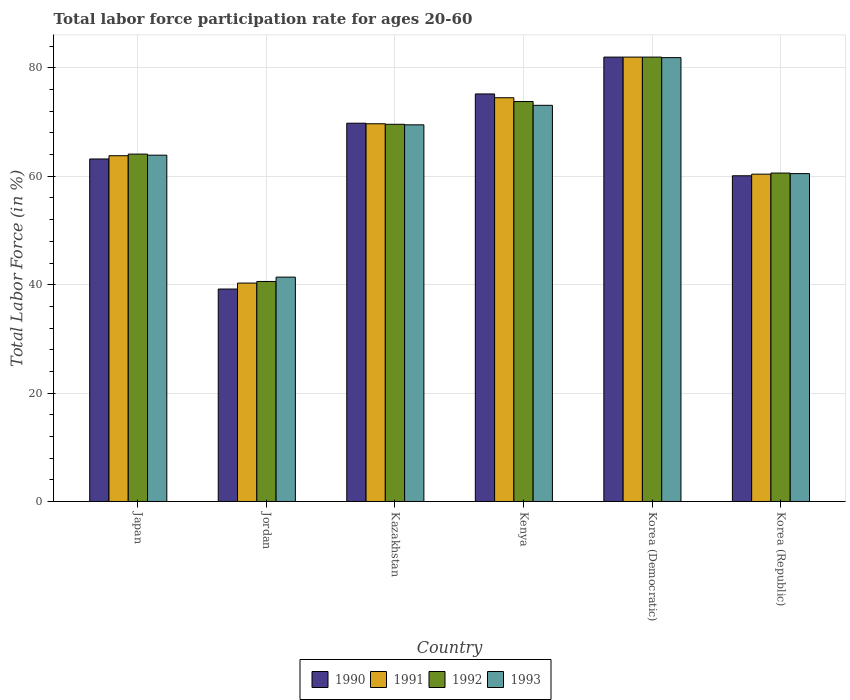Are the number of bars per tick equal to the number of legend labels?
Keep it short and to the point. Yes. Are the number of bars on each tick of the X-axis equal?
Ensure brevity in your answer.  Yes. How many bars are there on the 1st tick from the left?
Keep it short and to the point. 4. How many bars are there on the 2nd tick from the right?
Provide a short and direct response. 4. What is the label of the 1st group of bars from the left?
Keep it short and to the point. Japan. What is the labor force participation rate in 1992 in Japan?
Provide a short and direct response. 64.1. Across all countries, what is the maximum labor force participation rate in 1993?
Offer a terse response. 81.9. Across all countries, what is the minimum labor force participation rate in 1992?
Provide a short and direct response. 40.6. In which country was the labor force participation rate in 1993 maximum?
Provide a succinct answer. Korea (Democratic). In which country was the labor force participation rate in 1992 minimum?
Your answer should be very brief. Jordan. What is the total labor force participation rate in 1990 in the graph?
Keep it short and to the point. 389.5. What is the difference between the labor force participation rate in 1991 in Kazakhstan and that in Korea (Democratic)?
Offer a terse response. -12.3. What is the difference between the labor force participation rate in 1991 in Korea (Republic) and the labor force participation rate in 1990 in Japan?
Offer a terse response. -2.8. What is the average labor force participation rate in 1991 per country?
Offer a very short reply. 65.12. What is the difference between the labor force participation rate of/in 1991 and labor force participation rate of/in 1993 in Korea (Republic)?
Make the answer very short. -0.1. In how many countries, is the labor force participation rate in 1991 greater than 80 %?
Your answer should be very brief. 1. What is the ratio of the labor force participation rate in 1990 in Japan to that in Kenya?
Give a very brief answer. 0.84. Is the difference between the labor force participation rate in 1991 in Kazakhstan and Korea (Democratic) greater than the difference between the labor force participation rate in 1993 in Kazakhstan and Korea (Democratic)?
Make the answer very short. Yes. What is the difference between the highest and the second highest labor force participation rate in 1993?
Provide a succinct answer. -8.8. What is the difference between the highest and the lowest labor force participation rate in 1993?
Your answer should be very brief. 40.5. Is the sum of the labor force participation rate in 1992 in Jordan and Kenya greater than the maximum labor force participation rate in 1990 across all countries?
Ensure brevity in your answer.  Yes. Is it the case that in every country, the sum of the labor force participation rate in 1992 and labor force participation rate in 1991 is greater than the sum of labor force participation rate in 1990 and labor force participation rate in 1993?
Ensure brevity in your answer.  No. What does the 4th bar from the right in Jordan represents?
Provide a succinct answer. 1990. How many bars are there?
Your response must be concise. 24. How many countries are there in the graph?
Provide a succinct answer. 6. What is the difference between two consecutive major ticks on the Y-axis?
Offer a very short reply. 20. Are the values on the major ticks of Y-axis written in scientific E-notation?
Give a very brief answer. No. Does the graph contain any zero values?
Make the answer very short. No. Does the graph contain grids?
Offer a very short reply. Yes. Where does the legend appear in the graph?
Keep it short and to the point. Bottom center. What is the title of the graph?
Offer a very short reply. Total labor force participation rate for ages 20-60. Does "2002" appear as one of the legend labels in the graph?
Your response must be concise. No. What is the label or title of the Y-axis?
Keep it short and to the point. Total Labor Force (in %). What is the Total Labor Force (in %) of 1990 in Japan?
Your answer should be very brief. 63.2. What is the Total Labor Force (in %) in 1991 in Japan?
Make the answer very short. 63.8. What is the Total Labor Force (in %) of 1992 in Japan?
Provide a succinct answer. 64.1. What is the Total Labor Force (in %) of 1993 in Japan?
Provide a succinct answer. 63.9. What is the Total Labor Force (in %) of 1990 in Jordan?
Make the answer very short. 39.2. What is the Total Labor Force (in %) in 1991 in Jordan?
Your answer should be very brief. 40.3. What is the Total Labor Force (in %) in 1992 in Jordan?
Your response must be concise. 40.6. What is the Total Labor Force (in %) of 1993 in Jordan?
Provide a succinct answer. 41.4. What is the Total Labor Force (in %) in 1990 in Kazakhstan?
Provide a short and direct response. 69.8. What is the Total Labor Force (in %) of 1991 in Kazakhstan?
Provide a short and direct response. 69.7. What is the Total Labor Force (in %) in 1992 in Kazakhstan?
Your response must be concise. 69.6. What is the Total Labor Force (in %) in 1993 in Kazakhstan?
Give a very brief answer. 69.5. What is the Total Labor Force (in %) in 1990 in Kenya?
Provide a succinct answer. 75.2. What is the Total Labor Force (in %) in 1991 in Kenya?
Your answer should be compact. 74.5. What is the Total Labor Force (in %) in 1992 in Kenya?
Your answer should be compact. 73.8. What is the Total Labor Force (in %) in 1993 in Kenya?
Offer a very short reply. 73.1. What is the Total Labor Force (in %) in 1990 in Korea (Democratic)?
Ensure brevity in your answer.  82. What is the Total Labor Force (in %) of 1991 in Korea (Democratic)?
Your response must be concise. 82. What is the Total Labor Force (in %) in 1993 in Korea (Democratic)?
Your response must be concise. 81.9. What is the Total Labor Force (in %) in 1990 in Korea (Republic)?
Offer a terse response. 60.1. What is the Total Labor Force (in %) of 1991 in Korea (Republic)?
Ensure brevity in your answer.  60.4. What is the Total Labor Force (in %) in 1992 in Korea (Republic)?
Ensure brevity in your answer.  60.6. What is the Total Labor Force (in %) of 1993 in Korea (Republic)?
Offer a terse response. 60.5. Across all countries, what is the maximum Total Labor Force (in %) in 1991?
Give a very brief answer. 82. Across all countries, what is the maximum Total Labor Force (in %) of 1993?
Your answer should be compact. 81.9. Across all countries, what is the minimum Total Labor Force (in %) of 1990?
Your answer should be very brief. 39.2. Across all countries, what is the minimum Total Labor Force (in %) of 1991?
Provide a short and direct response. 40.3. Across all countries, what is the minimum Total Labor Force (in %) of 1992?
Your answer should be very brief. 40.6. Across all countries, what is the minimum Total Labor Force (in %) in 1993?
Your answer should be compact. 41.4. What is the total Total Labor Force (in %) of 1990 in the graph?
Keep it short and to the point. 389.5. What is the total Total Labor Force (in %) of 1991 in the graph?
Your answer should be very brief. 390.7. What is the total Total Labor Force (in %) in 1992 in the graph?
Keep it short and to the point. 390.7. What is the total Total Labor Force (in %) of 1993 in the graph?
Provide a short and direct response. 390.3. What is the difference between the Total Labor Force (in %) of 1993 in Japan and that in Jordan?
Offer a terse response. 22.5. What is the difference between the Total Labor Force (in %) in 1990 in Japan and that in Kazakhstan?
Provide a succinct answer. -6.6. What is the difference between the Total Labor Force (in %) of 1992 in Japan and that in Kazakhstan?
Provide a short and direct response. -5.5. What is the difference between the Total Labor Force (in %) in 1993 in Japan and that in Kazakhstan?
Provide a succinct answer. -5.6. What is the difference between the Total Labor Force (in %) of 1990 in Japan and that in Korea (Democratic)?
Your answer should be compact. -18.8. What is the difference between the Total Labor Force (in %) of 1991 in Japan and that in Korea (Democratic)?
Ensure brevity in your answer.  -18.2. What is the difference between the Total Labor Force (in %) of 1992 in Japan and that in Korea (Democratic)?
Offer a terse response. -17.9. What is the difference between the Total Labor Force (in %) in 1990 in Japan and that in Korea (Republic)?
Your response must be concise. 3.1. What is the difference between the Total Labor Force (in %) of 1991 in Japan and that in Korea (Republic)?
Your answer should be compact. 3.4. What is the difference between the Total Labor Force (in %) in 1990 in Jordan and that in Kazakhstan?
Provide a short and direct response. -30.6. What is the difference between the Total Labor Force (in %) in 1991 in Jordan and that in Kazakhstan?
Provide a succinct answer. -29.4. What is the difference between the Total Labor Force (in %) in 1992 in Jordan and that in Kazakhstan?
Offer a very short reply. -29. What is the difference between the Total Labor Force (in %) of 1993 in Jordan and that in Kazakhstan?
Give a very brief answer. -28.1. What is the difference between the Total Labor Force (in %) in 1990 in Jordan and that in Kenya?
Your answer should be very brief. -36. What is the difference between the Total Labor Force (in %) in 1991 in Jordan and that in Kenya?
Make the answer very short. -34.2. What is the difference between the Total Labor Force (in %) in 1992 in Jordan and that in Kenya?
Make the answer very short. -33.2. What is the difference between the Total Labor Force (in %) of 1993 in Jordan and that in Kenya?
Provide a short and direct response. -31.7. What is the difference between the Total Labor Force (in %) in 1990 in Jordan and that in Korea (Democratic)?
Provide a succinct answer. -42.8. What is the difference between the Total Labor Force (in %) of 1991 in Jordan and that in Korea (Democratic)?
Your answer should be compact. -41.7. What is the difference between the Total Labor Force (in %) in 1992 in Jordan and that in Korea (Democratic)?
Give a very brief answer. -41.4. What is the difference between the Total Labor Force (in %) in 1993 in Jordan and that in Korea (Democratic)?
Your response must be concise. -40.5. What is the difference between the Total Labor Force (in %) in 1990 in Jordan and that in Korea (Republic)?
Provide a short and direct response. -20.9. What is the difference between the Total Labor Force (in %) in 1991 in Jordan and that in Korea (Republic)?
Your answer should be very brief. -20.1. What is the difference between the Total Labor Force (in %) in 1993 in Jordan and that in Korea (Republic)?
Keep it short and to the point. -19.1. What is the difference between the Total Labor Force (in %) of 1991 in Kazakhstan and that in Kenya?
Ensure brevity in your answer.  -4.8. What is the difference between the Total Labor Force (in %) of 1992 in Kazakhstan and that in Kenya?
Make the answer very short. -4.2. What is the difference between the Total Labor Force (in %) of 1990 in Kazakhstan and that in Korea (Democratic)?
Provide a succinct answer. -12.2. What is the difference between the Total Labor Force (in %) in 1993 in Kazakhstan and that in Korea (Democratic)?
Offer a terse response. -12.4. What is the difference between the Total Labor Force (in %) in 1990 in Kazakhstan and that in Korea (Republic)?
Provide a succinct answer. 9.7. What is the difference between the Total Labor Force (in %) in 1991 in Kazakhstan and that in Korea (Republic)?
Your answer should be compact. 9.3. What is the difference between the Total Labor Force (in %) in 1993 in Kazakhstan and that in Korea (Republic)?
Ensure brevity in your answer.  9. What is the difference between the Total Labor Force (in %) of 1991 in Kenya and that in Korea (Democratic)?
Give a very brief answer. -7.5. What is the difference between the Total Labor Force (in %) in 1993 in Kenya and that in Korea (Democratic)?
Your response must be concise. -8.8. What is the difference between the Total Labor Force (in %) of 1990 in Korea (Democratic) and that in Korea (Republic)?
Your response must be concise. 21.9. What is the difference between the Total Labor Force (in %) of 1991 in Korea (Democratic) and that in Korea (Republic)?
Provide a succinct answer. 21.6. What is the difference between the Total Labor Force (in %) of 1992 in Korea (Democratic) and that in Korea (Republic)?
Keep it short and to the point. 21.4. What is the difference between the Total Labor Force (in %) in 1993 in Korea (Democratic) and that in Korea (Republic)?
Make the answer very short. 21.4. What is the difference between the Total Labor Force (in %) of 1990 in Japan and the Total Labor Force (in %) of 1991 in Jordan?
Your answer should be very brief. 22.9. What is the difference between the Total Labor Force (in %) of 1990 in Japan and the Total Labor Force (in %) of 1992 in Jordan?
Provide a succinct answer. 22.6. What is the difference between the Total Labor Force (in %) in 1990 in Japan and the Total Labor Force (in %) in 1993 in Jordan?
Your answer should be very brief. 21.8. What is the difference between the Total Labor Force (in %) of 1991 in Japan and the Total Labor Force (in %) of 1992 in Jordan?
Offer a terse response. 23.2. What is the difference between the Total Labor Force (in %) of 1991 in Japan and the Total Labor Force (in %) of 1993 in Jordan?
Your answer should be very brief. 22.4. What is the difference between the Total Labor Force (in %) in 1992 in Japan and the Total Labor Force (in %) in 1993 in Jordan?
Offer a terse response. 22.7. What is the difference between the Total Labor Force (in %) of 1990 in Japan and the Total Labor Force (in %) of 1993 in Kazakhstan?
Keep it short and to the point. -6.3. What is the difference between the Total Labor Force (in %) in 1991 in Japan and the Total Labor Force (in %) in 1993 in Kazakhstan?
Provide a succinct answer. -5.7. What is the difference between the Total Labor Force (in %) in 1992 in Japan and the Total Labor Force (in %) in 1993 in Kazakhstan?
Provide a short and direct response. -5.4. What is the difference between the Total Labor Force (in %) in 1990 in Japan and the Total Labor Force (in %) in 1992 in Kenya?
Offer a very short reply. -10.6. What is the difference between the Total Labor Force (in %) of 1990 in Japan and the Total Labor Force (in %) of 1993 in Kenya?
Offer a terse response. -9.9. What is the difference between the Total Labor Force (in %) in 1991 in Japan and the Total Labor Force (in %) in 1992 in Kenya?
Provide a short and direct response. -10. What is the difference between the Total Labor Force (in %) in 1991 in Japan and the Total Labor Force (in %) in 1993 in Kenya?
Your answer should be compact. -9.3. What is the difference between the Total Labor Force (in %) in 1990 in Japan and the Total Labor Force (in %) in 1991 in Korea (Democratic)?
Keep it short and to the point. -18.8. What is the difference between the Total Labor Force (in %) of 1990 in Japan and the Total Labor Force (in %) of 1992 in Korea (Democratic)?
Ensure brevity in your answer.  -18.8. What is the difference between the Total Labor Force (in %) in 1990 in Japan and the Total Labor Force (in %) in 1993 in Korea (Democratic)?
Offer a terse response. -18.7. What is the difference between the Total Labor Force (in %) of 1991 in Japan and the Total Labor Force (in %) of 1992 in Korea (Democratic)?
Your answer should be very brief. -18.2. What is the difference between the Total Labor Force (in %) of 1991 in Japan and the Total Labor Force (in %) of 1993 in Korea (Democratic)?
Offer a terse response. -18.1. What is the difference between the Total Labor Force (in %) of 1992 in Japan and the Total Labor Force (in %) of 1993 in Korea (Democratic)?
Provide a short and direct response. -17.8. What is the difference between the Total Labor Force (in %) of 1990 in Japan and the Total Labor Force (in %) of 1992 in Korea (Republic)?
Your answer should be very brief. 2.6. What is the difference between the Total Labor Force (in %) in 1990 in Japan and the Total Labor Force (in %) in 1993 in Korea (Republic)?
Give a very brief answer. 2.7. What is the difference between the Total Labor Force (in %) in 1991 in Japan and the Total Labor Force (in %) in 1992 in Korea (Republic)?
Offer a very short reply. 3.2. What is the difference between the Total Labor Force (in %) in 1992 in Japan and the Total Labor Force (in %) in 1993 in Korea (Republic)?
Offer a very short reply. 3.6. What is the difference between the Total Labor Force (in %) of 1990 in Jordan and the Total Labor Force (in %) of 1991 in Kazakhstan?
Your answer should be very brief. -30.5. What is the difference between the Total Labor Force (in %) in 1990 in Jordan and the Total Labor Force (in %) in 1992 in Kazakhstan?
Offer a very short reply. -30.4. What is the difference between the Total Labor Force (in %) of 1990 in Jordan and the Total Labor Force (in %) of 1993 in Kazakhstan?
Give a very brief answer. -30.3. What is the difference between the Total Labor Force (in %) in 1991 in Jordan and the Total Labor Force (in %) in 1992 in Kazakhstan?
Offer a very short reply. -29.3. What is the difference between the Total Labor Force (in %) in 1991 in Jordan and the Total Labor Force (in %) in 1993 in Kazakhstan?
Your answer should be very brief. -29.2. What is the difference between the Total Labor Force (in %) of 1992 in Jordan and the Total Labor Force (in %) of 1993 in Kazakhstan?
Make the answer very short. -28.9. What is the difference between the Total Labor Force (in %) in 1990 in Jordan and the Total Labor Force (in %) in 1991 in Kenya?
Your answer should be compact. -35.3. What is the difference between the Total Labor Force (in %) in 1990 in Jordan and the Total Labor Force (in %) in 1992 in Kenya?
Provide a short and direct response. -34.6. What is the difference between the Total Labor Force (in %) in 1990 in Jordan and the Total Labor Force (in %) in 1993 in Kenya?
Your answer should be compact. -33.9. What is the difference between the Total Labor Force (in %) in 1991 in Jordan and the Total Labor Force (in %) in 1992 in Kenya?
Provide a succinct answer. -33.5. What is the difference between the Total Labor Force (in %) in 1991 in Jordan and the Total Labor Force (in %) in 1993 in Kenya?
Your answer should be very brief. -32.8. What is the difference between the Total Labor Force (in %) in 1992 in Jordan and the Total Labor Force (in %) in 1993 in Kenya?
Ensure brevity in your answer.  -32.5. What is the difference between the Total Labor Force (in %) of 1990 in Jordan and the Total Labor Force (in %) of 1991 in Korea (Democratic)?
Make the answer very short. -42.8. What is the difference between the Total Labor Force (in %) of 1990 in Jordan and the Total Labor Force (in %) of 1992 in Korea (Democratic)?
Your answer should be very brief. -42.8. What is the difference between the Total Labor Force (in %) of 1990 in Jordan and the Total Labor Force (in %) of 1993 in Korea (Democratic)?
Your answer should be very brief. -42.7. What is the difference between the Total Labor Force (in %) in 1991 in Jordan and the Total Labor Force (in %) in 1992 in Korea (Democratic)?
Your answer should be very brief. -41.7. What is the difference between the Total Labor Force (in %) of 1991 in Jordan and the Total Labor Force (in %) of 1993 in Korea (Democratic)?
Provide a short and direct response. -41.6. What is the difference between the Total Labor Force (in %) of 1992 in Jordan and the Total Labor Force (in %) of 1993 in Korea (Democratic)?
Keep it short and to the point. -41.3. What is the difference between the Total Labor Force (in %) of 1990 in Jordan and the Total Labor Force (in %) of 1991 in Korea (Republic)?
Provide a short and direct response. -21.2. What is the difference between the Total Labor Force (in %) of 1990 in Jordan and the Total Labor Force (in %) of 1992 in Korea (Republic)?
Your answer should be very brief. -21.4. What is the difference between the Total Labor Force (in %) of 1990 in Jordan and the Total Labor Force (in %) of 1993 in Korea (Republic)?
Provide a short and direct response. -21.3. What is the difference between the Total Labor Force (in %) in 1991 in Jordan and the Total Labor Force (in %) in 1992 in Korea (Republic)?
Your answer should be compact. -20.3. What is the difference between the Total Labor Force (in %) of 1991 in Jordan and the Total Labor Force (in %) of 1993 in Korea (Republic)?
Offer a very short reply. -20.2. What is the difference between the Total Labor Force (in %) of 1992 in Jordan and the Total Labor Force (in %) of 1993 in Korea (Republic)?
Make the answer very short. -19.9. What is the difference between the Total Labor Force (in %) of 1990 in Kazakhstan and the Total Labor Force (in %) of 1991 in Kenya?
Provide a short and direct response. -4.7. What is the difference between the Total Labor Force (in %) in 1990 in Kazakhstan and the Total Labor Force (in %) in 1992 in Kenya?
Ensure brevity in your answer.  -4. What is the difference between the Total Labor Force (in %) in 1991 in Kazakhstan and the Total Labor Force (in %) in 1993 in Kenya?
Offer a very short reply. -3.4. What is the difference between the Total Labor Force (in %) in 1992 in Kazakhstan and the Total Labor Force (in %) in 1993 in Kenya?
Offer a very short reply. -3.5. What is the difference between the Total Labor Force (in %) of 1990 in Kazakhstan and the Total Labor Force (in %) of 1991 in Korea (Democratic)?
Your answer should be very brief. -12.2. What is the difference between the Total Labor Force (in %) of 1990 in Kazakhstan and the Total Labor Force (in %) of 1992 in Korea (Democratic)?
Your response must be concise. -12.2. What is the difference between the Total Labor Force (in %) in 1990 in Kazakhstan and the Total Labor Force (in %) in 1993 in Korea (Democratic)?
Offer a terse response. -12.1. What is the difference between the Total Labor Force (in %) in 1991 in Kazakhstan and the Total Labor Force (in %) in 1992 in Korea (Democratic)?
Your response must be concise. -12.3. What is the difference between the Total Labor Force (in %) of 1990 in Kazakhstan and the Total Labor Force (in %) of 1991 in Korea (Republic)?
Your answer should be compact. 9.4. What is the difference between the Total Labor Force (in %) of 1990 in Kazakhstan and the Total Labor Force (in %) of 1993 in Korea (Republic)?
Your answer should be very brief. 9.3. What is the difference between the Total Labor Force (in %) of 1991 in Kazakhstan and the Total Labor Force (in %) of 1992 in Korea (Republic)?
Keep it short and to the point. 9.1. What is the difference between the Total Labor Force (in %) in 1990 in Kenya and the Total Labor Force (in %) in 1991 in Korea (Democratic)?
Offer a very short reply. -6.8. What is the difference between the Total Labor Force (in %) in 1991 in Kenya and the Total Labor Force (in %) in 1992 in Korea (Democratic)?
Keep it short and to the point. -7.5. What is the difference between the Total Labor Force (in %) in 1990 in Kenya and the Total Labor Force (in %) in 1991 in Korea (Republic)?
Your response must be concise. 14.8. What is the difference between the Total Labor Force (in %) in 1991 in Kenya and the Total Labor Force (in %) in 1993 in Korea (Republic)?
Keep it short and to the point. 14. What is the difference between the Total Labor Force (in %) in 1992 in Kenya and the Total Labor Force (in %) in 1993 in Korea (Republic)?
Keep it short and to the point. 13.3. What is the difference between the Total Labor Force (in %) of 1990 in Korea (Democratic) and the Total Labor Force (in %) of 1991 in Korea (Republic)?
Ensure brevity in your answer.  21.6. What is the difference between the Total Labor Force (in %) of 1990 in Korea (Democratic) and the Total Labor Force (in %) of 1992 in Korea (Republic)?
Give a very brief answer. 21.4. What is the difference between the Total Labor Force (in %) in 1991 in Korea (Democratic) and the Total Labor Force (in %) in 1992 in Korea (Republic)?
Make the answer very short. 21.4. What is the average Total Labor Force (in %) of 1990 per country?
Give a very brief answer. 64.92. What is the average Total Labor Force (in %) of 1991 per country?
Provide a succinct answer. 65.12. What is the average Total Labor Force (in %) in 1992 per country?
Make the answer very short. 65.12. What is the average Total Labor Force (in %) of 1993 per country?
Keep it short and to the point. 65.05. What is the difference between the Total Labor Force (in %) in 1991 and Total Labor Force (in %) in 1992 in Japan?
Your response must be concise. -0.3. What is the difference between the Total Labor Force (in %) in 1990 and Total Labor Force (in %) in 1992 in Jordan?
Make the answer very short. -1.4. What is the difference between the Total Labor Force (in %) of 1990 and Total Labor Force (in %) of 1993 in Jordan?
Provide a short and direct response. -2.2. What is the difference between the Total Labor Force (in %) in 1990 and Total Labor Force (in %) in 1991 in Kazakhstan?
Offer a terse response. 0.1. What is the difference between the Total Labor Force (in %) in 1990 and Total Labor Force (in %) in 1992 in Kazakhstan?
Ensure brevity in your answer.  0.2. What is the difference between the Total Labor Force (in %) in 1990 and Total Labor Force (in %) in 1993 in Kazakhstan?
Make the answer very short. 0.3. What is the difference between the Total Labor Force (in %) in 1991 and Total Labor Force (in %) in 1993 in Kazakhstan?
Provide a short and direct response. 0.2. What is the difference between the Total Labor Force (in %) of 1991 and Total Labor Force (in %) of 1992 in Kenya?
Your answer should be very brief. 0.7. What is the difference between the Total Labor Force (in %) of 1990 and Total Labor Force (in %) of 1991 in Korea (Democratic)?
Your answer should be compact. 0. What is the difference between the Total Labor Force (in %) of 1990 and Total Labor Force (in %) of 1992 in Korea (Democratic)?
Provide a short and direct response. 0. What is the difference between the Total Labor Force (in %) in 1990 and Total Labor Force (in %) in 1993 in Korea (Democratic)?
Your answer should be compact. 0.1. What is the difference between the Total Labor Force (in %) in 1991 and Total Labor Force (in %) in 1992 in Korea (Democratic)?
Offer a very short reply. 0. What is the difference between the Total Labor Force (in %) in 1991 and Total Labor Force (in %) in 1993 in Korea (Democratic)?
Provide a short and direct response. 0.1. What is the difference between the Total Labor Force (in %) in 1992 and Total Labor Force (in %) in 1993 in Korea (Democratic)?
Offer a terse response. 0.1. What is the difference between the Total Labor Force (in %) of 1990 and Total Labor Force (in %) of 1992 in Korea (Republic)?
Your response must be concise. -0.5. What is the difference between the Total Labor Force (in %) of 1991 and Total Labor Force (in %) of 1993 in Korea (Republic)?
Offer a very short reply. -0.1. What is the ratio of the Total Labor Force (in %) in 1990 in Japan to that in Jordan?
Keep it short and to the point. 1.61. What is the ratio of the Total Labor Force (in %) of 1991 in Japan to that in Jordan?
Provide a short and direct response. 1.58. What is the ratio of the Total Labor Force (in %) in 1992 in Japan to that in Jordan?
Your answer should be compact. 1.58. What is the ratio of the Total Labor Force (in %) of 1993 in Japan to that in Jordan?
Make the answer very short. 1.54. What is the ratio of the Total Labor Force (in %) in 1990 in Japan to that in Kazakhstan?
Provide a succinct answer. 0.91. What is the ratio of the Total Labor Force (in %) of 1991 in Japan to that in Kazakhstan?
Make the answer very short. 0.92. What is the ratio of the Total Labor Force (in %) in 1992 in Japan to that in Kazakhstan?
Ensure brevity in your answer.  0.92. What is the ratio of the Total Labor Force (in %) in 1993 in Japan to that in Kazakhstan?
Provide a succinct answer. 0.92. What is the ratio of the Total Labor Force (in %) in 1990 in Japan to that in Kenya?
Provide a short and direct response. 0.84. What is the ratio of the Total Labor Force (in %) of 1991 in Japan to that in Kenya?
Your response must be concise. 0.86. What is the ratio of the Total Labor Force (in %) of 1992 in Japan to that in Kenya?
Keep it short and to the point. 0.87. What is the ratio of the Total Labor Force (in %) of 1993 in Japan to that in Kenya?
Your response must be concise. 0.87. What is the ratio of the Total Labor Force (in %) of 1990 in Japan to that in Korea (Democratic)?
Make the answer very short. 0.77. What is the ratio of the Total Labor Force (in %) in 1991 in Japan to that in Korea (Democratic)?
Ensure brevity in your answer.  0.78. What is the ratio of the Total Labor Force (in %) in 1992 in Japan to that in Korea (Democratic)?
Ensure brevity in your answer.  0.78. What is the ratio of the Total Labor Force (in %) in 1993 in Japan to that in Korea (Democratic)?
Provide a short and direct response. 0.78. What is the ratio of the Total Labor Force (in %) of 1990 in Japan to that in Korea (Republic)?
Your answer should be very brief. 1.05. What is the ratio of the Total Labor Force (in %) in 1991 in Japan to that in Korea (Republic)?
Offer a terse response. 1.06. What is the ratio of the Total Labor Force (in %) in 1992 in Japan to that in Korea (Republic)?
Provide a succinct answer. 1.06. What is the ratio of the Total Labor Force (in %) of 1993 in Japan to that in Korea (Republic)?
Provide a succinct answer. 1.06. What is the ratio of the Total Labor Force (in %) in 1990 in Jordan to that in Kazakhstan?
Your answer should be compact. 0.56. What is the ratio of the Total Labor Force (in %) of 1991 in Jordan to that in Kazakhstan?
Offer a terse response. 0.58. What is the ratio of the Total Labor Force (in %) of 1992 in Jordan to that in Kazakhstan?
Provide a short and direct response. 0.58. What is the ratio of the Total Labor Force (in %) in 1993 in Jordan to that in Kazakhstan?
Make the answer very short. 0.6. What is the ratio of the Total Labor Force (in %) in 1990 in Jordan to that in Kenya?
Your response must be concise. 0.52. What is the ratio of the Total Labor Force (in %) in 1991 in Jordan to that in Kenya?
Keep it short and to the point. 0.54. What is the ratio of the Total Labor Force (in %) in 1992 in Jordan to that in Kenya?
Keep it short and to the point. 0.55. What is the ratio of the Total Labor Force (in %) in 1993 in Jordan to that in Kenya?
Offer a terse response. 0.57. What is the ratio of the Total Labor Force (in %) of 1990 in Jordan to that in Korea (Democratic)?
Your response must be concise. 0.48. What is the ratio of the Total Labor Force (in %) of 1991 in Jordan to that in Korea (Democratic)?
Your answer should be compact. 0.49. What is the ratio of the Total Labor Force (in %) in 1992 in Jordan to that in Korea (Democratic)?
Give a very brief answer. 0.5. What is the ratio of the Total Labor Force (in %) of 1993 in Jordan to that in Korea (Democratic)?
Ensure brevity in your answer.  0.51. What is the ratio of the Total Labor Force (in %) of 1990 in Jordan to that in Korea (Republic)?
Give a very brief answer. 0.65. What is the ratio of the Total Labor Force (in %) of 1991 in Jordan to that in Korea (Republic)?
Provide a short and direct response. 0.67. What is the ratio of the Total Labor Force (in %) in 1992 in Jordan to that in Korea (Republic)?
Ensure brevity in your answer.  0.67. What is the ratio of the Total Labor Force (in %) in 1993 in Jordan to that in Korea (Republic)?
Your answer should be very brief. 0.68. What is the ratio of the Total Labor Force (in %) in 1990 in Kazakhstan to that in Kenya?
Offer a terse response. 0.93. What is the ratio of the Total Labor Force (in %) in 1991 in Kazakhstan to that in Kenya?
Provide a succinct answer. 0.94. What is the ratio of the Total Labor Force (in %) of 1992 in Kazakhstan to that in Kenya?
Your answer should be compact. 0.94. What is the ratio of the Total Labor Force (in %) of 1993 in Kazakhstan to that in Kenya?
Offer a very short reply. 0.95. What is the ratio of the Total Labor Force (in %) in 1990 in Kazakhstan to that in Korea (Democratic)?
Ensure brevity in your answer.  0.85. What is the ratio of the Total Labor Force (in %) of 1992 in Kazakhstan to that in Korea (Democratic)?
Ensure brevity in your answer.  0.85. What is the ratio of the Total Labor Force (in %) of 1993 in Kazakhstan to that in Korea (Democratic)?
Offer a very short reply. 0.85. What is the ratio of the Total Labor Force (in %) in 1990 in Kazakhstan to that in Korea (Republic)?
Provide a short and direct response. 1.16. What is the ratio of the Total Labor Force (in %) of 1991 in Kazakhstan to that in Korea (Republic)?
Offer a terse response. 1.15. What is the ratio of the Total Labor Force (in %) in 1992 in Kazakhstan to that in Korea (Republic)?
Your answer should be very brief. 1.15. What is the ratio of the Total Labor Force (in %) in 1993 in Kazakhstan to that in Korea (Republic)?
Provide a succinct answer. 1.15. What is the ratio of the Total Labor Force (in %) of 1990 in Kenya to that in Korea (Democratic)?
Give a very brief answer. 0.92. What is the ratio of the Total Labor Force (in %) in 1991 in Kenya to that in Korea (Democratic)?
Give a very brief answer. 0.91. What is the ratio of the Total Labor Force (in %) in 1992 in Kenya to that in Korea (Democratic)?
Your answer should be very brief. 0.9. What is the ratio of the Total Labor Force (in %) of 1993 in Kenya to that in Korea (Democratic)?
Ensure brevity in your answer.  0.89. What is the ratio of the Total Labor Force (in %) in 1990 in Kenya to that in Korea (Republic)?
Give a very brief answer. 1.25. What is the ratio of the Total Labor Force (in %) of 1991 in Kenya to that in Korea (Republic)?
Offer a very short reply. 1.23. What is the ratio of the Total Labor Force (in %) in 1992 in Kenya to that in Korea (Republic)?
Provide a succinct answer. 1.22. What is the ratio of the Total Labor Force (in %) of 1993 in Kenya to that in Korea (Republic)?
Offer a very short reply. 1.21. What is the ratio of the Total Labor Force (in %) in 1990 in Korea (Democratic) to that in Korea (Republic)?
Offer a terse response. 1.36. What is the ratio of the Total Labor Force (in %) in 1991 in Korea (Democratic) to that in Korea (Republic)?
Your answer should be very brief. 1.36. What is the ratio of the Total Labor Force (in %) in 1992 in Korea (Democratic) to that in Korea (Republic)?
Provide a succinct answer. 1.35. What is the ratio of the Total Labor Force (in %) of 1993 in Korea (Democratic) to that in Korea (Republic)?
Give a very brief answer. 1.35. What is the difference between the highest and the second highest Total Labor Force (in %) of 1990?
Provide a short and direct response. 6.8. What is the difference between the highest and the second highest Total Labor Force (in %) of 1992?
Your response must be concise. 8.2. What is the difference between the highest and the second highest Total Labor Force (in %) of 1993?
Offer a terse response. 8.8. What is the difference between the highest and the lowest Total Labor Force (in %) in 1990?
Keep it short and to the point. 42.8. What is the difference between the highest and the lowest Total Labor Force (in %) in 1991?
Your answer should be compact. 41.7. What is the difference between the highest and the lowest Total Labor Force (in %) in 1992?
Make the answer very short. 41.4. What is the difference between the highest and the lowest Total Labor Force (in %) in 1993?
Offer a terse response. 40.5. 